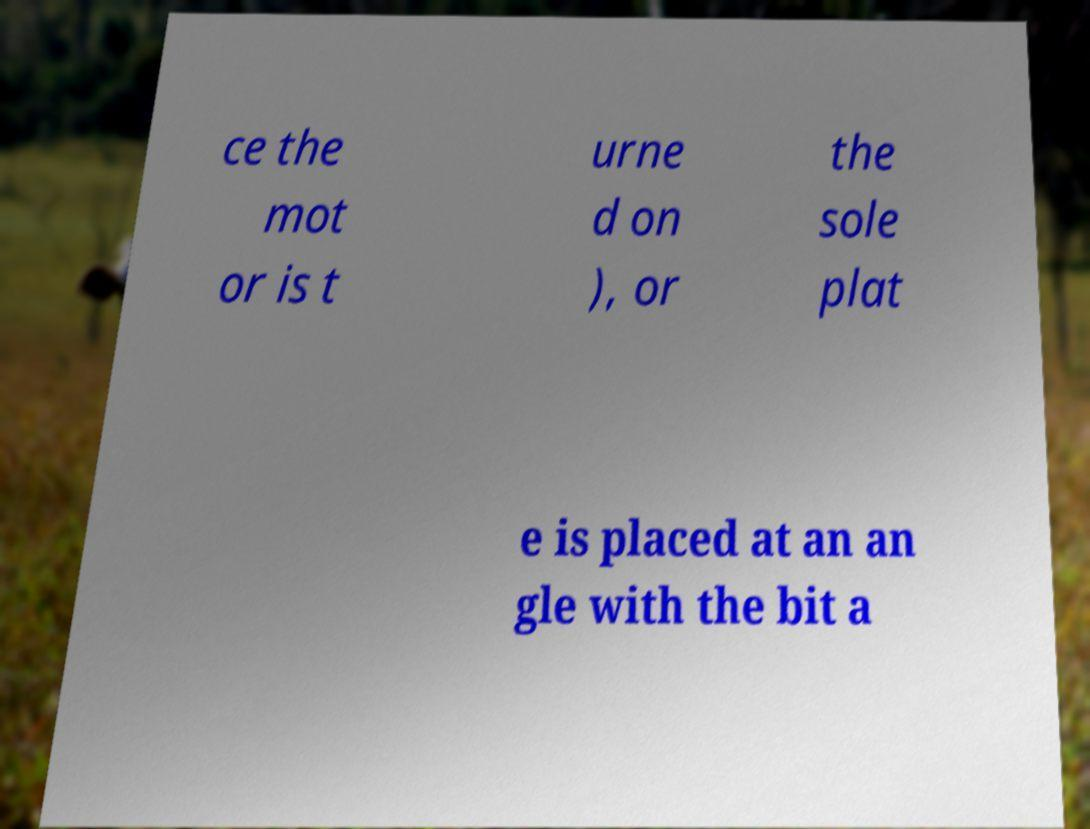Can you accurately transcribe the text from the provided image for me? ce the mot or is t urne d on ), or the sole plat e is placed at an an gle with the bit a 